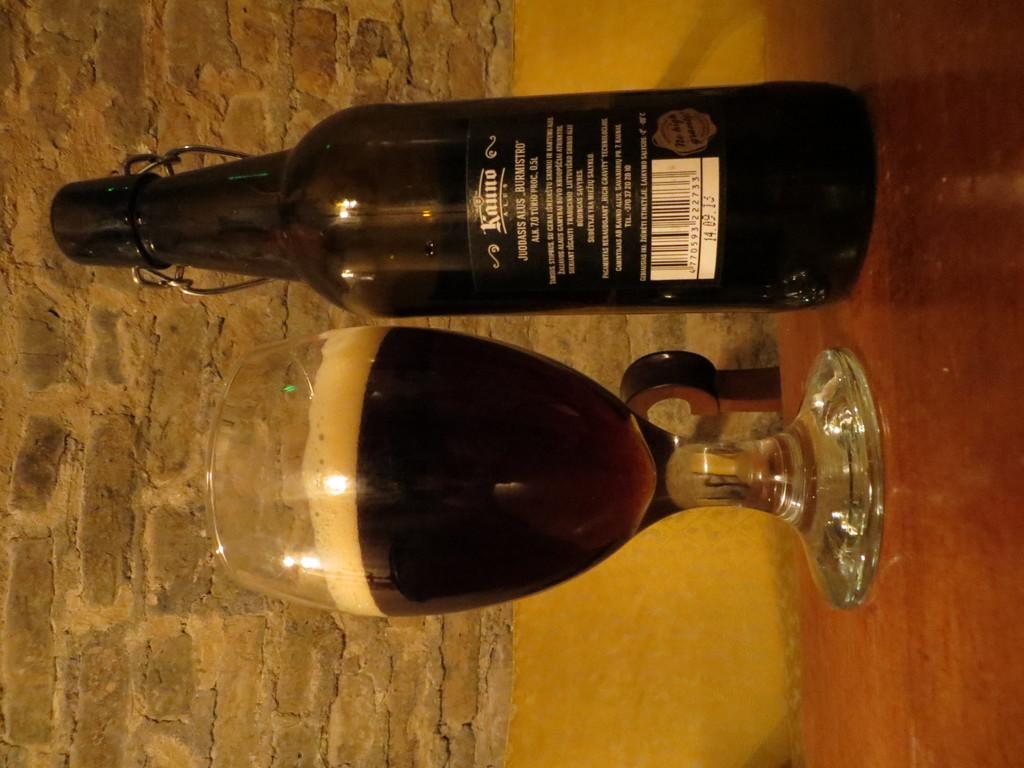<image>
Present a compact description of the photo's key features. A bottle is marked 14.09.13 below the bar code. 